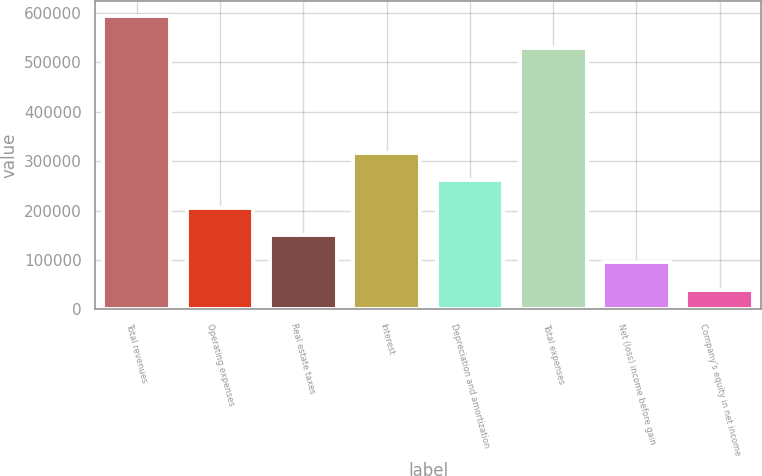Convert chart. <chart><loc_0><loc_0><loc_500><loc_500><bar_chart><fcel>Total revenues<fcel>Operating expenses<fcel>Real estate taxes<fcel>Interest<fcel>Depreciation and amortization<fcel>Total expenses<fcel>Net (loss) income before gain<fcel>Company's equity in net income<nl><fcel>593159<fcel>205673<fcel>150317<fcel>316383<fcel>261028<fcel>528258<fcel>94962.2<fcel>39607<nl></chart> 